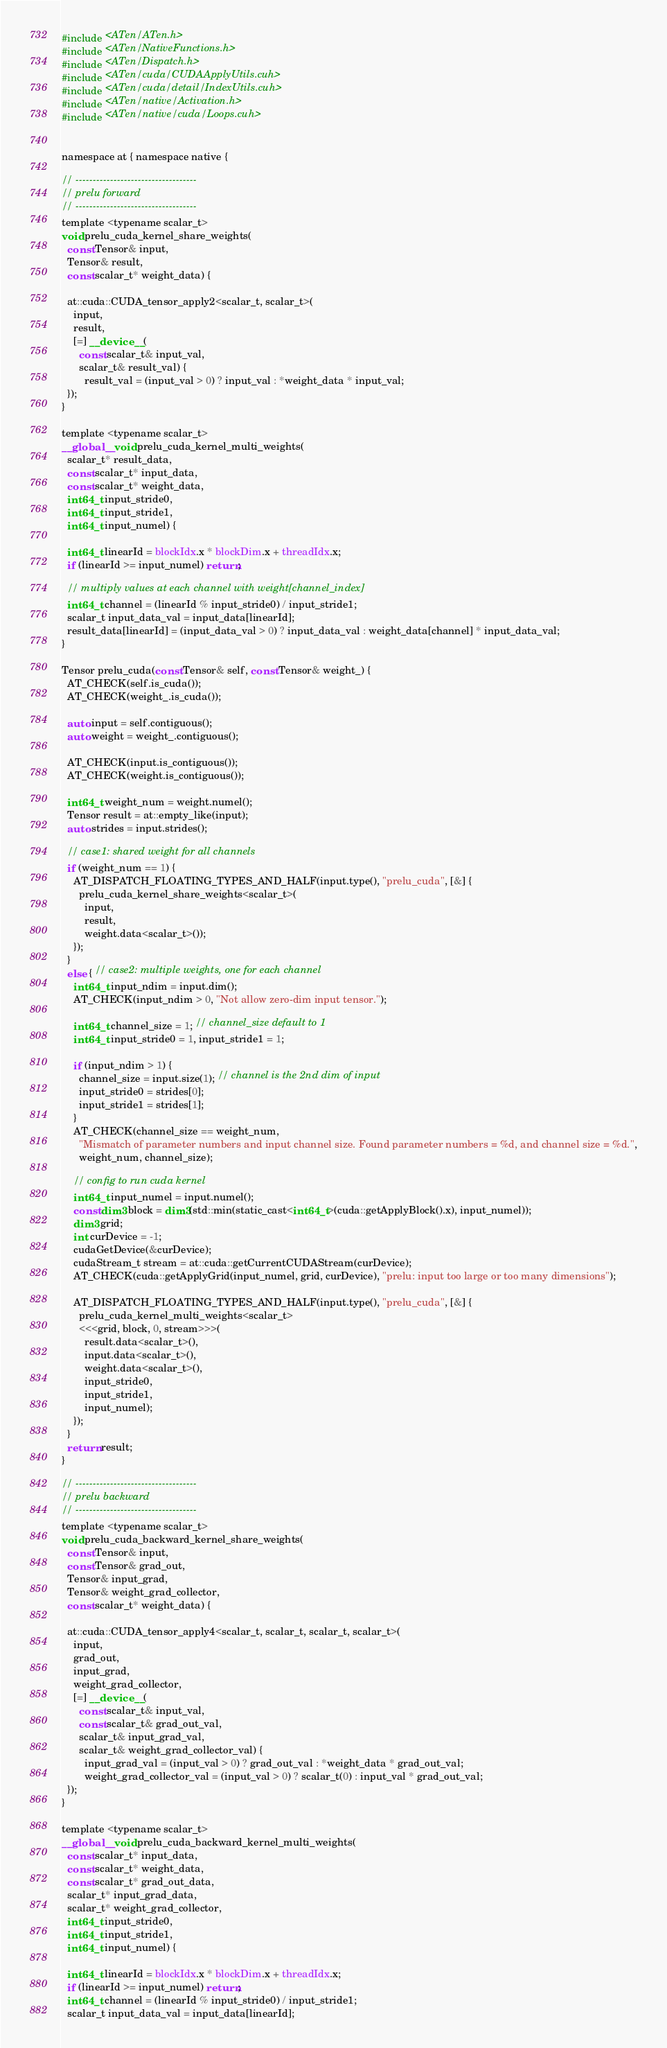<code> <loc_0><loc_0><loc_500><loc_500><_Cuda_>#include <ATen/ATen.h>
#include <ATen/NativeFunctions.h>
#include <ATen/Dispatch.h>
#include <ATen/cuda/CUDAApplyUtils.cuh>
#include <ATen/cuda/detail/IndexUtils.cuh>
#include <ATen/native/Activation.h>
#include <ATen/native/cuda/Loops.cuh>


namespace at { namespace native {

// -----------------------------------
// prelu forward
// -----------------------------------
template <typename scalar_t>
void prelu_cuda_kernel_share_weights(
  const Tensor& input,
  Tensor& result,
  const scalar_t* weight_data) {

  at::cuda::CUDA_tensor_apply2<scalar_t, scalar_t>(
    input,
    result,
    [=] __device__ (
      const scalar_t& input_val,
      scalar_t& result_val) {
        result_val = (input_val > 0) ? input_val : *weight_data * input_val;
  });
}

template <typename scalar_t>
__global__ void prelu_cuda_kernel_multi_weights(
  scalar_t* result_data,
  const scalar_t* input_data,
  const scalar_t* weight_data,
  int64_t input_stride0,
  int64_t input_stride1,
  int64_t input_numel) {

  int64_t linearId = blockIdx.x * blockDim.x + threadIdx.x;
  if (linearId >= input_numel) return;

  // multiply values at each channel with weight[channel_index]
  int64_t channel = (linearId % input_stride0) / input_stride1;
  scalar_t input_data_val = input_data[linearId];
  result_data[linearId] = (input_data_val > 0) ? input_data_val : weight_data[channel] * input_data_val;
}

Tensor prelu_cuda(const Tensor& self, const Tensor& weight_) {
  AT_CHECK(self.is_cuda());
  AT_CHECK(weight_.is_cuda());

  auto input = self.contiguous();
  auto weight = weight_.contiguous();

  AT_CHECK(input.is_contiguous());
  AT_CHECK(weight.is_contiguous());

  int64_t weight_num = weight.numel();
  Tensor result = at::empty_like(input);
  auto strides = input.strides();

  // case1: shared weight for all channels
  if (weight_num == 1) {
    AT_DISPATCH_FLOATING_TYPES_AND_HALF(input.type(), "prelu_cuda", [&] {
      prelu_cuda_kernel_share_weights<scalar_t>(
        input,
        result,
        weight.data<scalar_t>());
    });
  }
  else { // case2: multiple weights, one for each channel
    int64_t input_ndim = input.dim();
    AT_CHECK(input_ndim > 0, "Not allow zero-dim input tensor.");

    int64_t channel_size = 1; // channel_size default to 1
    int64_t input_stride0 = 1, input_stride1 = 1;

    if (input_ndim > 1) {
      channel_size = input.size(1); // channel is the 2nd dim of input
      input_stride0 = strides[0];
      input_stride1 = strides[1];
    }
    AT_CHECK(channel_size == weight_num,
      "Mismatch of parameter numbers and input channel size. Found parameter numbers = %d, and channel size = %d.",
      weight_num, channel_size);

    // config to run cuda kernel
    int64_t input_numel = input.numel();
    const dim3 block = dim3(std::min(static_cast<int64_t>(cuda::getApplyBlock().x), input_numel));
    dim3 grid;
    int curDevice = -1;
    cudaGetDevice(&curDevice);
    cudaStream_t stream = at::cuda::getCurrentCUDAStream(curDevice);
    AT_CHECK(cuda::getApplyGrid(input_numel, grid, curDevice), "prelu: input too large or too many dimensions");

    AT_DISPATCH_FLOATING_TYPES_AND_HALF(input.type(), "prelu_cuda", [&] {
      prelu_cuda_kernel_multi_weights<scalar_t>
      <<<grid, block, 0, stream>>>(
        result.data<scalar_t>(),
        input.data<scalar_t>(),
        weight.data<scalar_t>(),
        input_stride0,
        input_stride1,
        input_numel);
    });
  }
  return result;
}

// -----------------------------------
// prelu backward
// -----------------------------------
template <typename scalar_t>
void prelu_cuda_backward_kernel_share_weights(
  const Tensor& input,
  const Tensor& grad_out,
  Tensor& input_grad,
  Tensor& weight_grad_collector,
  const scalar_t* weight_data) {

  at::cuda::CUDA_tensor_apply4<scalar_t, scalar_t, scalar_t, scalar_t>(
    input,
    grad_out,
    input_grad,
    weight_grad_collector,
    [=] __device__ (
      const scalar_t& input_val,
      const scalar_t& grad_out_val,
      scalar_t& input_grad_val,
      scalar_t& weight_grad_collector_val) {
        input_grad_val = (input_val > 0) ? grad_out_val : *weight_data * grad_out_val;
        weight_grad_collector_val = (input_val > 0) ? scalar_t(0) : input_val * grad_out_val;
  });
}

template <typename scalar_t>
__global__ void prelu_cuda_backward_kernel_multi_weights(
  const scalar_t* input_data,
  const scalar_t* weight_data,
  const scalar_t* grad_out_data,
  scalar_t* input_grad_data,
  scalar_t* weight_grad_collector,
  int64_t input_stride0,
  int64_t input_stride1,
  int64_t input_numel) {

  int64_t linearId = blockIdx.x * blockDim.x + threadIdx.x;
  if (linearId >= input_numel) return;
  int64_t channel = (linearId % input_stride0) / input_stride1;
  scalar_t input_data_val = input_data[linearId];</code> 